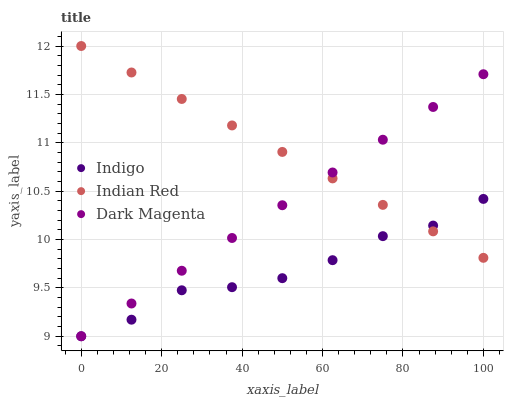Does Indigo have the minimum area under the curve?
Answer yes or no. Yes. Does Indian Red have the maximum area under the curve?
Answer yes or no. Yes. Does Dark Magenta have the minimum area under the curve?
Answer yes or no. No. Does Dark Magenta have the maximum area under the curve?
Answer yes or no. No. Is Indian Red the smoothest?
Answer yes or no. Yes. Is Indigo the roughest?
Answer yes or no. Yes. Is Dark Magenta the smoothest?
Answer yes or no. No. Is Dark Magenta the roughest?
Answer yes or no. No. Does Indigo have the lowest value?
Answer yes or no. Yes. Does Indian Red have the lowest value?
Answer yes or no. No. Does Indian Red have the highest value?
Answer yes or no. Yes. Does Dark Magenta have the highest value?
Answer yes or no. No. Does Indigo intersect Indian Red?
Answer yes or no. Yes. Is Indigo less than Indian Red?
Answer yes or no. No. Is Indigo greater than Indian Red?
Answer yes or no. No. 